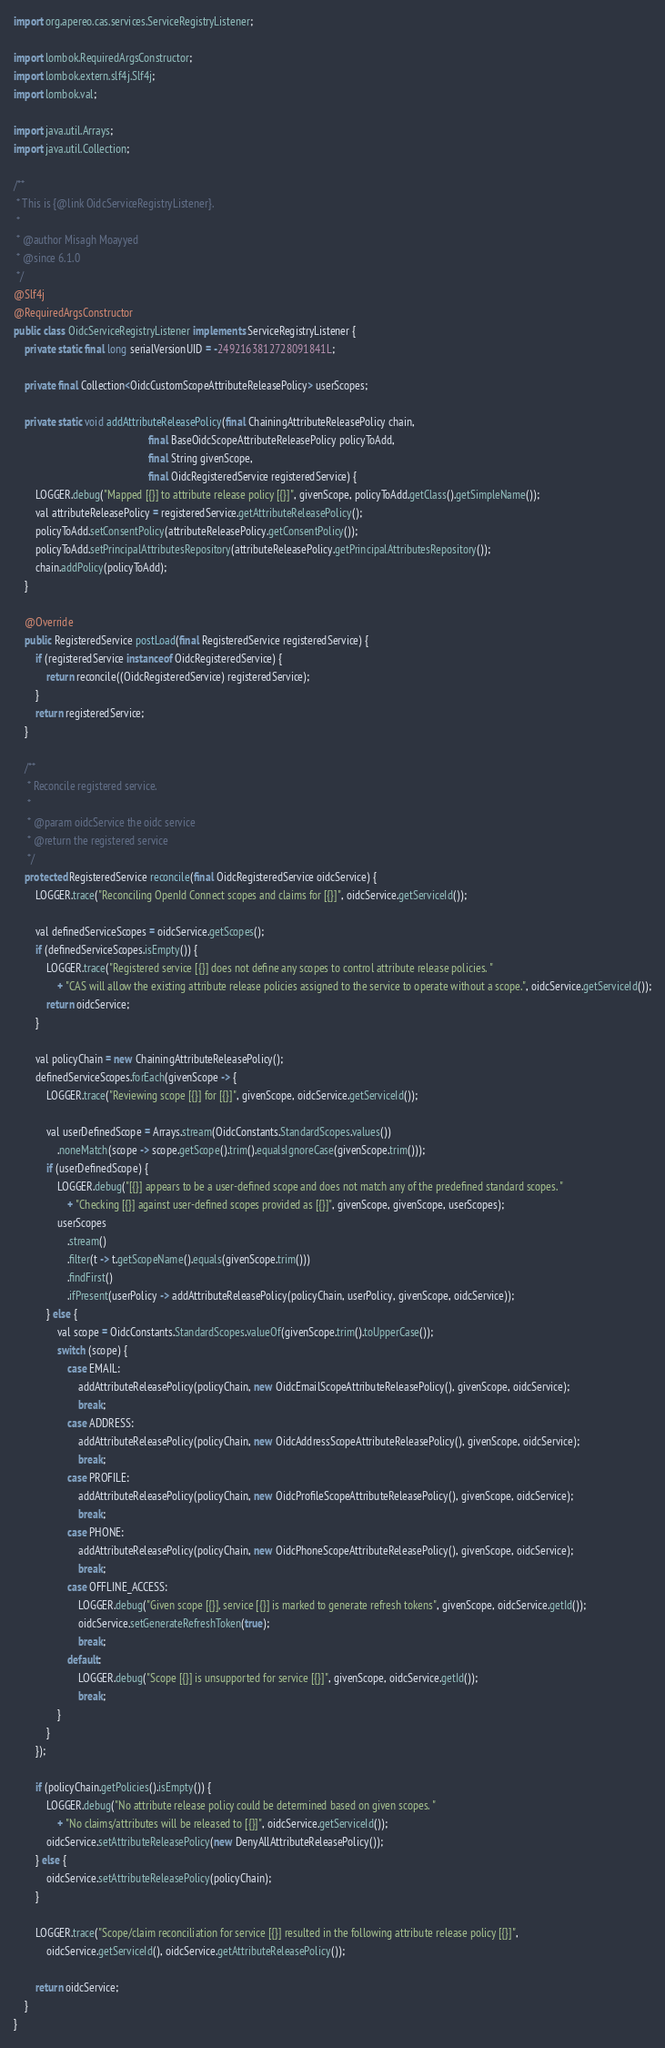Convert code to text. <code><loc_0><loc_0><loc_500><loc_500><_Java_>import org.apereo.cas.services.ServiceRegistryListener;

import lombok.RequiredArgsConstructor;
import lombok.extern.slf4j.Slf4j;
import lombok.val;

import java.util.Arrays;
import java.util.Collection;

/**
 * This is {@link OidcServiceRegistryListener}.
 *
 * @author Misagh Moayyed
 * @since 6.1.0
 */
@Slf4j
@RequiredArgsConstructor
public class OidcServiceRegistryListener implements ServiceRegistryListener {
    private static final long serialVersionUID = -2492163812728091841L;

    private final Collection<OidcCustomScopeAttributeReleasePolicy> userScopes;

    private static void addAttributeReleasePolicy(final ChainingAttributeReleasePolicy chain,
                                                  final BaseOidcScopeAttributeReleasePolicy policyToAdd,
                                                  final String givenScope,
                                                  final OidcRegisteredService registeredService) {
        LOGGER.debug("Mapped [{}] to attribute release policy [{}]", givenScope, policyToAdd.getClass().getSimpleName());
        val attributeReleasePolicy = registeredService.getAttributeReleasePolicy();
        policyToAdd.setConsentPolicy(attributeReleasePolicy.getConsentPolicy());
        policyToAdd.setPrincipalAttributesRepository(attributeReleasePolicy.getPrincipalAttributesRepository());
        chain.addPolicy(policyToAdd);
    }

    @Override
    public RegisteredService postLoad(final RegisteredService registeredService) {
        if (registeredService instanceof OidcRegisteredService) {
            return reconcile((OidcRegisteredService) registeredService);
        }
        return registeredService;
    }

    /**
     * Reconcile registered service.
     *
     * @param oidcService the oidc service
     * @return the registered service
     */
    protected RegisteredService reconcile(final OidcRegisteredService oidcService) {
        LOGGER.trace("Reconciling OpenId Connect scopes and claims for [{}]", oidcService.getServiceId());

        val definedServiceScopes = oidcService.getScopes();
        if (definedServiceScopes.isEmpty()) {
            LOGGER.trace("Registered service [{}] does not define any scopes to control attribute release policies. "
                + "CAS will allow the existing attribute release policies assigned to the service to operate without a scope.", oidcService.getServiceId());
            return oidcService;
        }

        val policyChain = new ChainingAttributeReleasePolicy();
        definedServiceScopes.forEach(givenScope -> {
            LOGGER.trace("Reviewing scope [{}] for [{}]", givenScope, oidcService.getServiceId());

            val userDefinedScope = Arrays.stream(OidcConstants.StandardScopes.values())
                .noneMatch(scope -> scope.getScope().trim().equalsIgnoreCase(givenScope.trim()));
            if (userDefinedScope) {
                LOGGER.debug("[{}] appears to be a user-defined scope and does not match any of the predefined standard scopes. "
                    + "Checking [{}] against user-defined scopes provided as [{}]", givenScope, givenScope, userScopes);
                userScopes
                    .stream()
                    .filter(t -> t.getScopeName().equals(givenScope.trim()))
                    .findFirst()
                    .ifPresent(userPolicy -> addAttributeReleasePolicy(policyChain, userPolicy, givenScope, oidcService));
            } else {
                val scope = OidcConstants.StandardScopes.valueOf(givenScope.trim().toUpperCase());
                switch (scope) {
                    case EMAIL:
                        addAttributeReleasePolicy(policyChain, new OidcEmailScopeAttributeReleasePolicy(), givenScope, oidcService);
                        break;
                    case ADDRESS:
                        addAttributeReleasePolicy(policyChain, new OidcAddressScopeAttributeReleasePolicy(), givenScope, oidcService);
                        break;
                    case PROFILE:
                        addAttributeReleasePolicy(policyChain, new OidcProfileScopeAttributeReleasePolicy(), givenScope, oidcService);
                        break;
                    case PHONE:
                        addAttributeReleasePolicy(policyChain, new OidcPhoneScopeAttributeReleasePolicy(), givenScope, oidcService);
                        break;
                    case OFFLINE_ACCESS:
                        LOGGER.debug("Given scope [{}], service [{}] is marked to generate refresh tokens", givenScope, oidcService.getId());
                        oidcService.setGenerateRefreshToken(true);
                        break;
                    default:
                        LOGGER.debug("Scope [{}] is unsupported for service [{}]", givenScope, oidcService.getId());
                        break;
                }
            }
        });

        if (policyChain.getPolicies().isEmpty()) {
            LOGGER.debug("No attribute release policy could be determined based on given scopes. "
                + "No claims/attributes will be released to [{}]", oidcService.getServiceId());
            oidcService.setAttributeReleasePolicy(new DenyAllAttributeReleasePolicy());
        } else {
            oidcService.setAttributeReleasePolicy(policyChain);
        }

        LOGGER.trace("Scope/claim reconciliation for service [{}] resulted in the following attribute release policy [{}]",
            oidcService.getServiceId(), oidcService.getAttributeReleasePolicy());

        return oidcService;
    }
}
</code> 